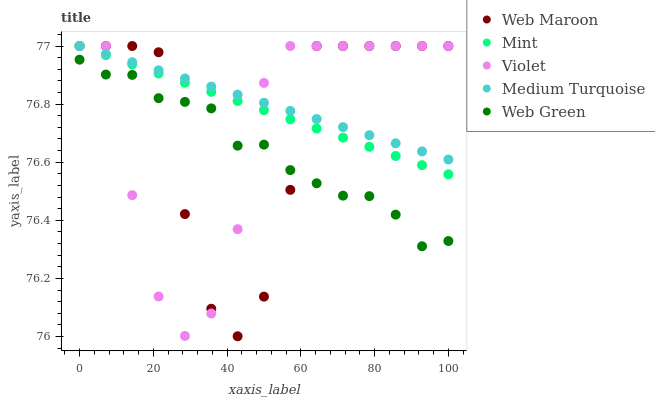Does Web Green have the minimum area under the curve?
Answer yes or no. Yes. Does Medium Turquoise have the maximum area under the curve?
Answer yes or no. Yes. Does Web Maroon have the minimum area under the curve?
Answer yes or no. No. Does Web Maroon have the maximum area under the curve?
Answer yes or no. No. Is Medium Turquoise the smoothest?
Answer yes or no. Yes. Is Web Maroon the roughest?
Answer yes or no. Yes. Is Web Green the smoothest?
Answer yes or no. No. Is Web Green the roughest?
Answer yes or no. No. Does Web Maroon have the lowest value?
Answer yes or no. Yes. Does Web Green have the lowest value?
Answer yes or no. No. Does Violet have the highest value?
Answer yes or no. Yes. Does Web Green have the highest value?
Answer yes or no. No. Is Web Green less than Mint?
Answer yes or no. Yes. Is Medium Turquoise greater than Web Green?
Answer yes or no. Yes. Does Medium Turquoise intersect Mint?
Answer yes or no. Yes. Is Medium Turquoise less than Mint?
Answer yes or no. No. Is Medium Turquoise greater than Mint?
Answer yes or no. No. Does Web Green intersect Mint?
Answer yes or no. No. 